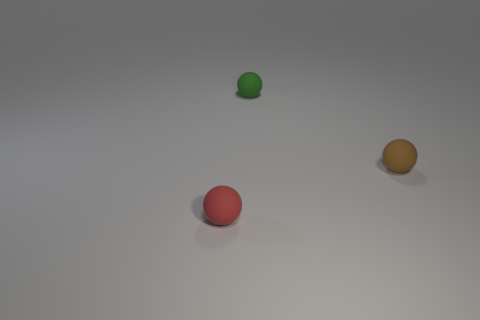Add 1 red spheres. How many objects exist? 4 Add 2 small red spheres. How many small red spheres exist? 3 Subtract 1 green spheres. How many objects are left? 2 Subtract all big purple shiny spheres. Subtract all tiny brown rubber balls. How many objects are left? 2 Add 1 small matte balls. How many small matte balls are left? 4 